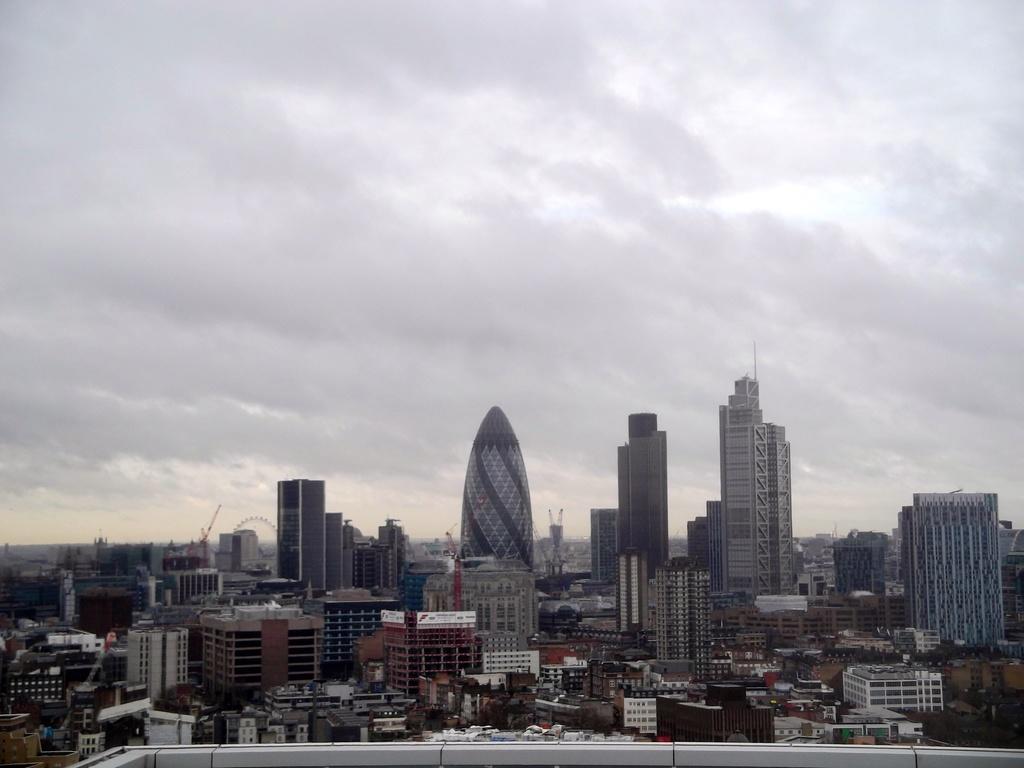Could you give a brief overview of what you see in this image? This is a aerial view. In this image we can see buildings, trees, sky and clouds. 